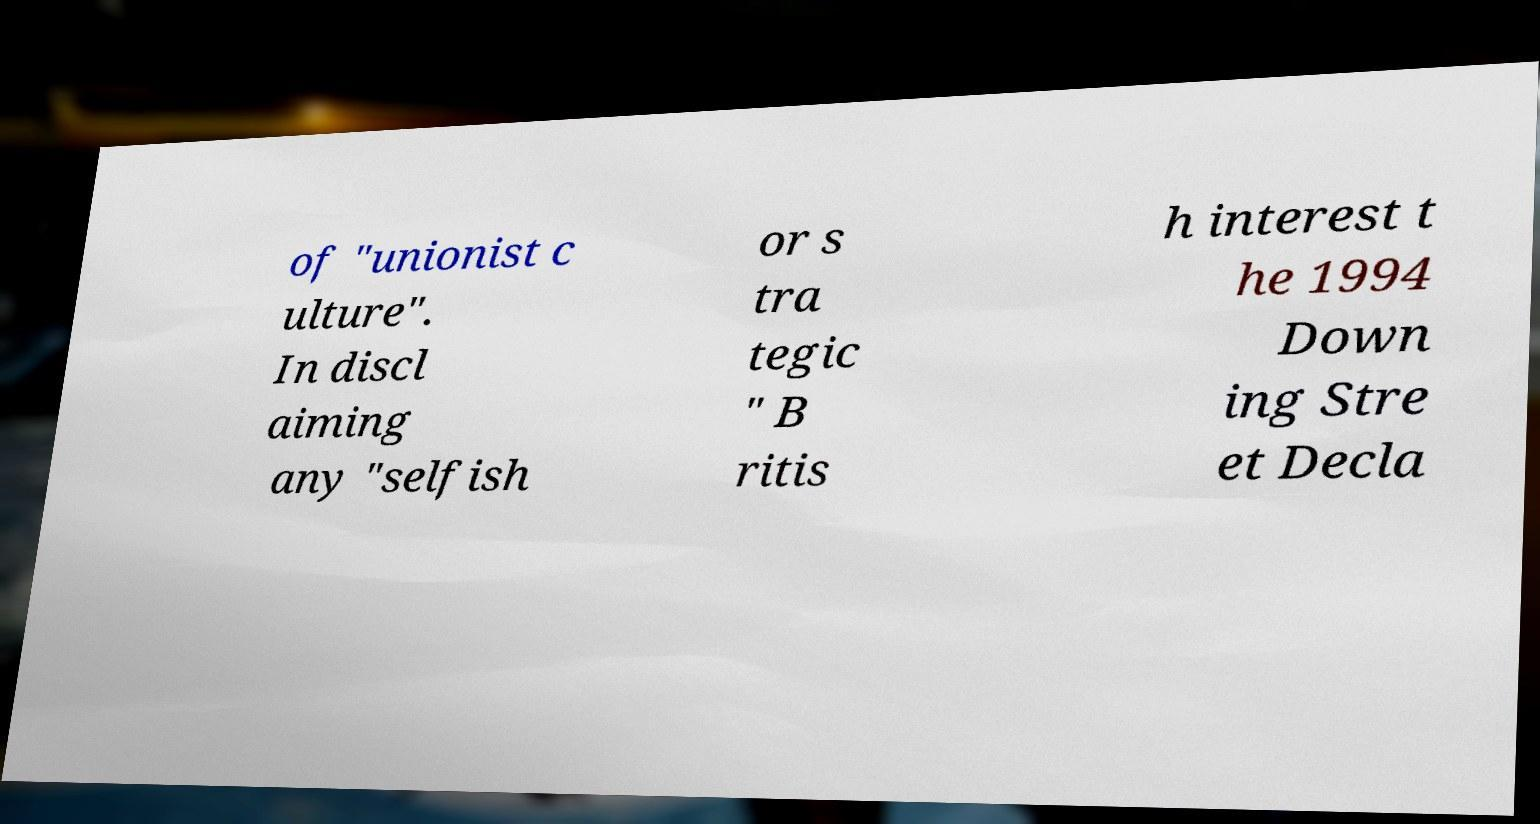There's text embedded in this image that I need extracted. Can you transcribe it verbatim? of "unionist c ulture". In discl aiming any "selfish or s tra tegic " B ritis h interest t he 1994 Down ing Stre et Decla 